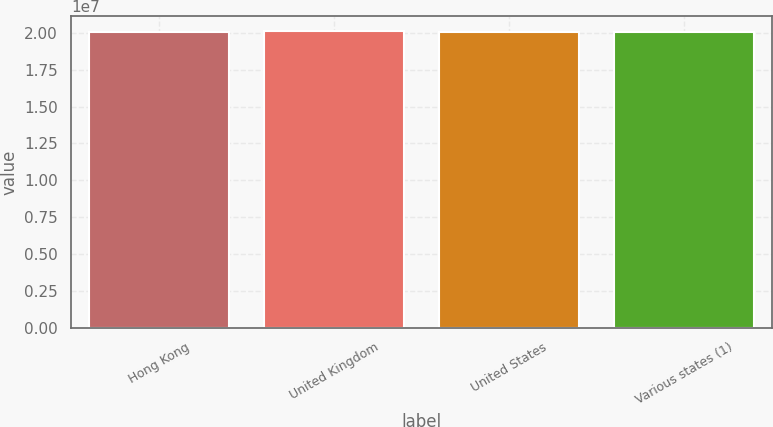<chart> <loc_0><loc_0><loc_500><loc_500><bar_chart><fcel>Hong Kong<fcel>United Kingdom<fcel>United States<fcel>Various states (1)<nl><fcel>2.0072e+07<fcel>2.0112e+07<fcel>2.0042e+07<fcel>2.0052e+07<nl></chart> 